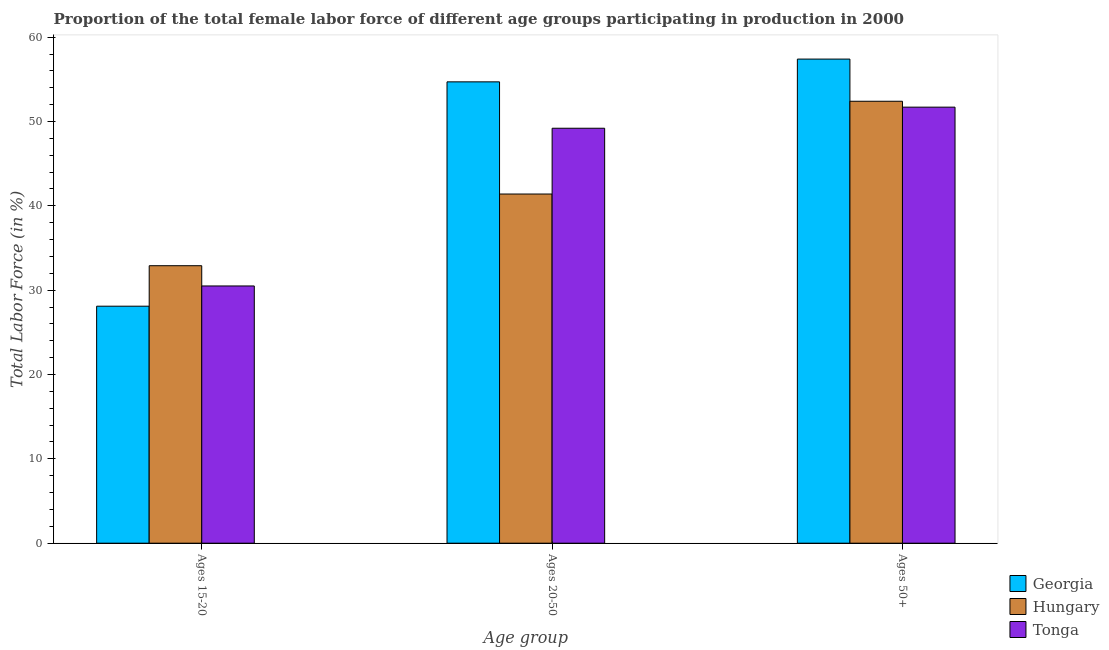How many bars are there on the 3rd tick from the left?
Offer a very short reply. 3. How many bars are there on the 2nd tick from the right?
Your answer should be very brief. 3. What is the label of the 1st group of bars from the left?
Offer a very short reply. Ages 15-20. What is the percentage of female labor force within the age group 20-50 in Georgia?
Ensure brevity in your answer.  54.7. Across all countries, what is the maximum percentage of female labor force within the age group 15-20?
Your answer should be very brief. 32.9. Across all countries, what is the minimum percentage of female labor force within the age group 20-50?
Your response must be concise. 41.4. In which country was the percentage of female labor force within the age group 20-50 maximum?
Ensure brevity in your answer.  Georgia. In which country was the percentage of female labor force within the age group 15-20 minimum?
Your answer should be compact. Georgia. What is the total percentage of female labor force within the age group 20-50 in the graph?
Ensure brevity in your answer.  145.3. What is the difference between the percentage of female labor force within the age group 15-20 in Georgia and that in Hungary?
Your answer should be compact. -4.8. What is the difference between the percentage of female labor force within the age group 15-20 in Hungary and the percentage of female labor force above age 50 in Georgia?
Your answer should be very brief. -24.5. What is the average percentage of female labor force above age 50 per country?
Your answer should be very brief. 53.83. What is the difference between the percentage of female labor force within the age group 20-50 and percentage of female labor force within the age group 15-20 in Georgia?
Your response must be concise. 26.6. What is the ratio of the percentage of female labor force within the age group 15-20 in Hungary to that in Tonga?
Ensure brevity in your answer.  1.08. Is the percentage of female labor force above age 50 in Hungary less than that in Tonga?
Your answer should be compact. No. Is the difference between the percentage of female labor force within the age group 20-50 in Georgia and Tonga greater than the difference between the percentage of female labor force within the age group 15-20 in Georgia and Tonga?
Your response must be concise. Yes. What is the difference between the highest and the lowest percentage of female labor force within the age group 20-50?
Provide a short and direct response. 13.3. In how many countries, is the percentage of female labor force within the age group 20-50 greater than the average percentage of female labor force within the age group 20-50 taken over all countries?
Keep it short and to the point. 2. What does the 1st bar from the left in Ages 50+ represents?
Offer a terse response. Georgia. What does the 2nd bar from the right in Ages 15-20 represents?
Your answer should be very brief. Hungary. Are all the bars in the graph horizontal?
Your answer should be very brief. No. How many countries are there in the graph?
Ensure brevity in your answer.  3. Does the graph contain grids?
Ensure brevity in your answer.  No. How many legend labels are there?
Provide a succinct answer. 3. How are the legend labels stacked?
Your answer should be compact. Vertical. What is the title of the graph?
Give a very brief answer. Proportion of the total female labor force of different age groups participating in production in 2000. What is the label or title of the X-axis?
Your response must be concise. Age group. What is the Total Labor Force (in %) in Georgia in Ages 15-20?
Provide a short and direct response. 28.1. What is the Total Labor Force (in %) in Hungary in Ages 15-20?
Your answer should be very brief. 32.9. What is the Total Labor Force (in %) of Tonga in Ages 15-20?
Keep it short and to the point. 30.5. What is the Total Labor Force (in %) of Georgia in Ages 20-50?
Your answer should be very brief. 54.7. What is the Total Labor Force (in %) in Hungary in Ages 20-50?
Your answer should be compact. 41.4. What is the Total Labor Force (in %) in Tonga in Ages 20-50?
Provide a short and direct response. 49.2. What is the Total Labor Force (in %) of Georgia in Ages 50+?
Give a very brief answer. 57.4. What is the Total Labor Force (in %) of Hungary in Ages 50+?
Provide a succinct answer. 52.4. What is the Total Labor Force (in %) in Tonga in Ages 50+?
Offer a terse response. 51.7. Across all Age group, what is the maximum Total Labor Force (in %) in Georgia?
Offer a very short reply. 57.4. Across all Age group, what is the maximum Total Labor Force (in %) in Hungary?
Your answer should be compact. 52.4. Across all Age group, what is the maximum Total Labor Force (in %) in Tonga?
Provide a short and direct response. 51.7. Across all Age group, what is the minimum Total Labor Force (in %) of Georgia?
Provide a short and direct response. 28.1. Across all Age group, what is the minimum Total Labor Force (in %) in Hungary?
Your answer should be very brief. 32.9. Across all Age group, what is the minimum Total Labor Force (in %) of Tonga?
Provide a succinct answer. 30.5. What is the total Total Labor Force (in %) in Georgia in the graph?
Your answer should be very brief. 140.2. What is the total Total Labor Force (in %) in Hungary in the graph?
Provide a short and direct response. 126.7. What is the total Total Labor Force (in %) in Tonga in the graph?
Provide a succinct answer. 131.4. What is the difference between the Total Labor Force (in %) of Georgia in Ages 15-20 and that in Ages 20-50?
Give a very brief answer. -26.6. What is the difference between the Total Labor Force (in %) of Hungary in Ages 15-20 and that in Ages 20-50?
Make the answer very short. -8.5. What is the difference between the Total Labor Force (in %) in Tonga in Ages 15-20 and that in Ages 20-50?
Provide a succinct answer. -18.7. What is the difference between the Total Labor Force (in %) of Georgia in Ages 15-20 and that in Ages 50+?
Make the answer very short. -29.3. What is the difference between the Total Labor Force (in %) in Hungary in Ages 15-20 and that in Ages 50+?
Keep it short and to the point. -19.5. What is the difference between the Total Labor Force (in %) in Tonga in Ages 15-20 and that in Ages 50+?
Make the answer very short. -21.2. What is the difference between the Total Labor Force (in %) in Georgia in Ages 20-50 and that in Ages 50+?
Provide a short and direct response. -2.7. What is the difference between the Total Labor Force (in %) in Hungary in Ages 20-50 and that in Ages 50+?
Ensure brevity in your answer.  -11. What is the difference between the Total Labor Force (in %) of Tonga in Ages 20-50 and that in Ages 50+?
Keep it short and to the point. -2.5. What is the difference between the Total Labor Force (in %) of Georgia in Ages 15-20 and the Total Labor Force (in %) of Hungary in Ages 20-50?
Provide a short and direct response. -13.3. What is the difference between the Total Labor Force (in %) of Georgia in Ages 15-20 and the Total Labor Force (in %) of Tonga in Ages 20-50?
Offer a very short reply. -21.1. What is the difference between the Total Labor Force (in %) of Hungary in Ages 15-20 and the Total Labor Force (in %) of Tonga in Ages 20-50?
Give a very brief answer. -16.3. What is the difference between the Total Labor Force (in %) in Georgia in Ages 15-20 and the Total Labor Force (in %) in Hungary in Ages 50+?
Provide a short and direct response. -24.3. What is the difference between the Total Labor Force (in %) of Georgia in Ages 15-20 and the Total Labor Force (in %) of Tonga in Ages 50+?
Provide a succinct answer. -23.6. What is the difference between the Total Labor Force (in %) of Hungary in Ages 15-20 and the Total Labor Force (in %) of Tonga in Ages 50+?
Offer a very short reply. -18.8. What is the difference between the Total Labor Force (in %) in Hungary in Ages 20-50 and the Total Labor Force (in %) in Tonga in Ages 50+?
Offer a terse response. -10.3. What is the average Total Labor Force (in %) of Georgia per Age group?
Your response must be concise. 46.73. What is the average Total Labor Force (in %) of Hungary per Age group?
Your response must be concise. 42.23. What is the average Total Labor Force (in %) of Tonga per Age group?
Offer a terse response. 43.8. What is the difference between the Total Labor Force (in %) in Georgia and Total Labor Force (in %) in Tonga in Ages 15-20?
Give a very brief answer. -2.4. What is the difference between the Total Labor Force (in %) in Hungary and Total Labor Force (in %) in Tonga in Ages 15-20?
Your answer should be very brief. 2.4. What is the difference between the Total Labor Force (in %) in Georgia and Total Labor Force (in %) in Hungary in Ages 20-50?
Your answer should be very brief. 13.3. What is the difference between the Total Labor Force (in %) of Georgia and Total Labor Force (in %) of Tonga in Ages 50+?
Your response must be concise. 5.7. What is the ratio of the Total Labor Force (in %) in Georgia in Ages 15-20 to that in Ages 20-50?
Ensure brevity in your answer.  0.51. What is the ratio of the Total Labor Force (in %) of Hungary in Ages 15-20 to that in Ages 20-50?
Your response must be concise. 0.79. What is the ratio of the Total Labor Force (in %) of Tonga in Ages 15-20 to that in Ages 20-50?
Offer a very short reply. 0.62. What is the ratio of the Total Labor Force (in %) of Georgia in Ages 15-20 to that in Ages 50+?
Your answer should be compact. 0.49. What is the ratio of the Total Labor Force (in %) in Hungary in Ages 15-20 to that in Ages 50+?
Provide a short and direct response. 0.63. What is the ratio of the Total Labor Force (in %) in Tonga in Ages 15-20 to that in Ages 50+?
Offer a terse response. 0.59. What is the ratio of the Total Labor Force (in %) of Georgia in Ages 20-50 to that in Ages 50+?
Your answer should be compact. 0.95. What is the ratio of the Total Labor Force (in %) in Hungary in Ages 20-50 to that in Ages 50+?
Offer a terse response. 0.79. What is the ratio of the Total Labor Force (in %) of Tonga in Ages 20-50 to that in Ages 50+?
Provide a succinct answer. 0.95. What is the difference between the highest and the second highest Total Labor Force (in %) in Tonga?
Provide a succinct answer. 2.5. What is the difference between the highest and the lowest Total Labor Force (in %) of Georgia?
Your answer should be compact. 29.3. What is the difference between the highest and the lowest Total Labor Force (in %) in Tonga?
Make the answer very short. 21.2. 